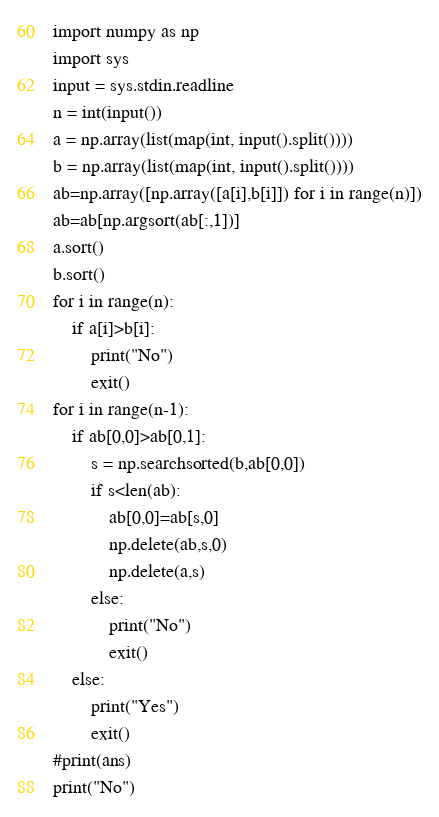<code> <loc_0><loc_0><loc_500><loc_500><_Python_>import numpy as np
import sys
input = sys.stdin.readline
n = int(input())
a = np.array(list(map(int, input().split())))
b = np.array(list(map(int, input().split())))
ab=np.array([np.array([a[i],b[i]]) for i in range(n)])
ab=ab[np.argsort(ab[:,1])]
a.sort()
b.sort()
for i in range(n):
    if a[i]>b[i]:
        print("No")
        exit()
for i in range(n-1):
    if ab[0,0]>ab[0,1]:
        s = np.searchsorted(b,ab[0,0])
        if s<len(ab):
            ab[0,0]=ab[s,0]
            np.delete(ab,s,0)
            np.delete(a,s)
        else:
            print("No")
            exit()
    else:
        print("Yes")
        exit()
#print(ans)
print("No")
</code> 